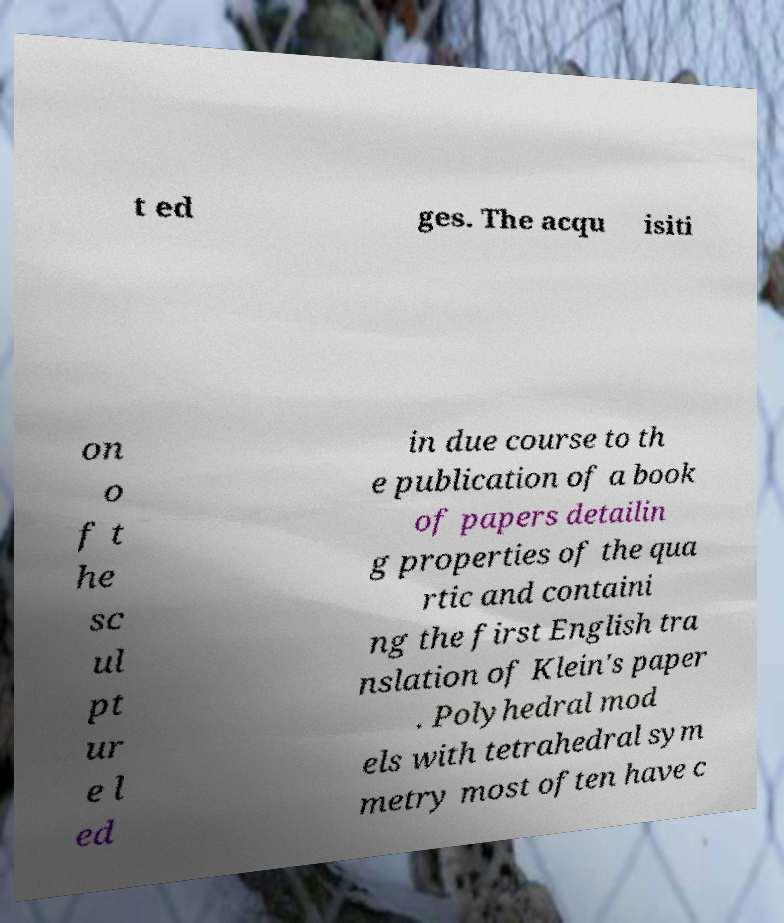Could you assist in decoding the text presented in this image and type it out clearly? t ed ges. The acqu isiti on o f t he sc ul pt ur e l ed in due course to th e publication of a book of papers detailin g properties of the qua rtic and containi ng the first English tra nslation of Klein's paper . Polyhedral mod els with tetrahedral sym metry most often have c 